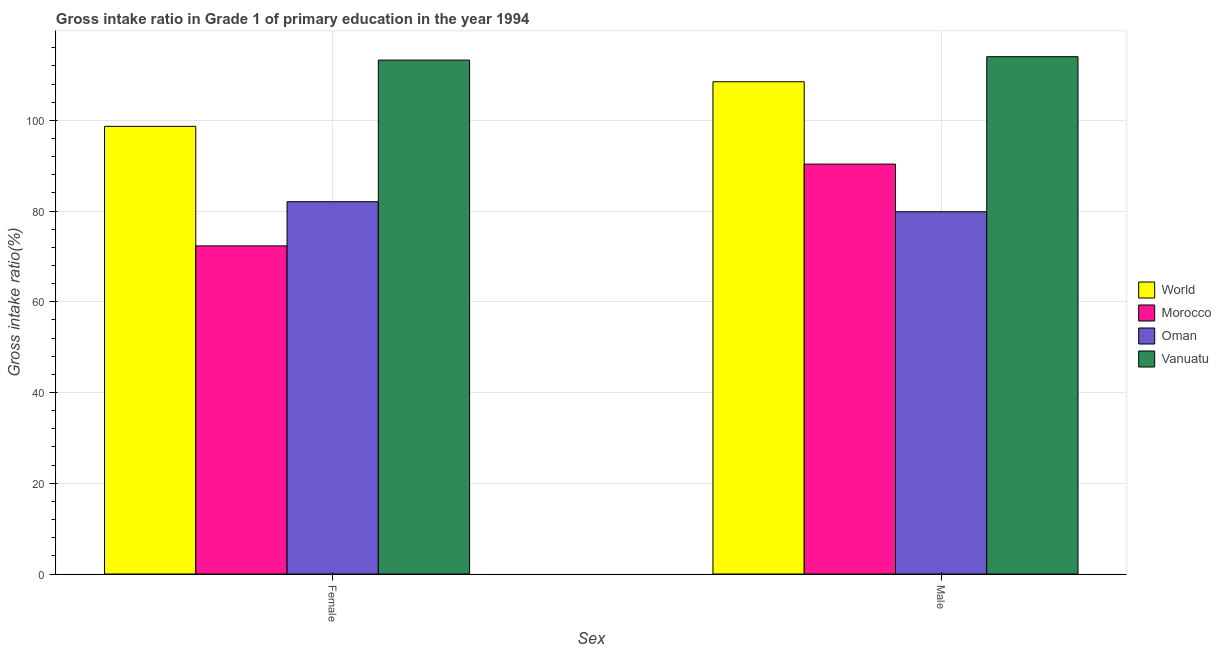How many different coloured bars are there?
Offer a terse response. 4. How many groups of bars are there?
Provide a short and direct response. 2. Are the number of bars on each tick of the X-axis equal?
Ensure brevity in your answer.  Yes. How many bars are there on the 2nd tick from the left?
Your answer should be compact. 4. What is the label of the 2nd group of bars from the left?
Provide a succinct answer. Male. What is the gross intake ratio(male) in Morocco?
Keep it short and to the point. 90.37. Across all countries, what is the maximum gross intake ratio(female)?
Your answer should be very brief. 113.3. Across all countries, what is the minimum gross intake ratio(male)?
Provide a succinct answer. 79.86. In which country was the gross intake ratio(male) maximum?
Your answer should be compact. Vanuatu. In which country was the gross intake ratio(female) minimum?
Offer a very short reply. Morocco. What is the total gross intake ratio(female) in the graph?
Offer a terse response. 366.41. What is the difference between the gross intake ratio(male) in Oman and that in Vanuatu?
Provide a succinct answer. -34.19. What is the difference between the gross intake ratio(female) in Vanuatu and the gross intake ratio(male) in Morocco?
Give a very brief answer. 22.93. What is the average gross intake ratio(female) per country?
Provide a succinct answer. 91.6. What is the difference between the gross intake ratio(male) and gross intake ratio(female) in Morocco?
Your answer should be very brief. 18.03. What is the ratio of the gross intake ratio(female) in Vanuatu to that in World?
Make the answer very short. 1.15. Is the gross intake ratio(male) in Vanuatu less than that in Morocco?
Keep it short and to the point. No. What does the 3rd bar from the left in Female represents?
Make the answer very short. Oman. What does the 1st bar from the right in Female represents?
Make the answer very short. Vanuatu. How many bars are there?
Offer a terse response. 8. Are all the bars in the graph horizontal?
Your answer should be very brief. No. How many countries are there in the graph?
Ensure brevity in your answer.  4. What is the difference between two consecutive major ticks on the Y-axis?
Offer a very short reply. 20. Are the values on the major ticks of Y-axis written in scientific E-notation?
Ensure brevity in your answer.  No. Does the graph contain any zero values?
Offer a very short reply. No. Where does the legend appear in the graph?
Provide a short and direct response. Center right. How many legend labels are there?
Your answer should be very brief. 4. What is the title of the graph?
Keep it short and to the point. Gross intake ratio in Grade 1 of primary education in the year 1994. What is the label or title of the X-axis?
Provide a succinct answer. Sex. What is the label or title of the Y-axis?
Offer a terse response. Gross intake ratio(%). What is the Gross intake ratio(%) in World in Female?
Your answer should be very brief. 98.69. What is the Gross intake ratio(%) of Morocco in Female?
Make the answer very short. 72.34. What is the Gross intake ratio(%) of Oman in Female?
Provide a short and direct response. 82.08. What is the Gross intake ratio(%) of Vanuatu in Female?
Provide a short and direct response. 113.3. What is the Gross intake ratio(%) in World in Male?
Give a very brief answer. 108.52. What is the Gross intake ratio(%) of Morocco in Male?
Make the answer very short. 90.37. What is the Gross intake ratio(%) in Oman in Male?
Offer a very short reply. 79.86. What is the Gross intake ratio(%) of Vanuatu in Male?
Give a very brief answer. 114.05. Across all Sex, what is the maximum Gross intake ratio(%) of World?
Your response must be concise. 108.52. Across all Sex, what is the maximum Gross intake ratio(%) in Morocco?
Make the answer very short. 90.37. Across all Sex, what is the maximum Gross intake ratio(%) of Oman?
Keep it short and to the point. 82.08. Across all Sex, what is the maximum Gross intake ratio(%) in Vanuatu?
Make the answer very short. 114.05. Across all Sex, what is the minimum Gross intake ratio(%) in World?
Your response must be concise. 98.69. Across all Sex, what is the minimum Gross intake ratio(%) of Morocco?
Provide a short and direct response. 72.34. Across all Sex, what is the minimum Gross intake ratio(%) in Oman?
Offer a very short reply. 79.86. Across all Sex, what is the minimum Gross intake ratio(%) of Vanuatu?
Keep it short and to the point. 113.3. What is the total Gross intake ratio(%) of World in the graph?
Make the answer very short. 207.21. What is the total Gross intake ratio(%) of Morocco in the graph?
Provide a succinct answer. 162.71. What is the total Gross intake ratio(%) of Oman in the graph?
Ensure brevity in your answer.  161.94. What is the total Gross intake ratio(%) of Vanuatu in the graph?
Keep it short and to the point. 227.35. What is the difference between the Gross intake ratio(%) in World in Female and that in Male?
Ensure brevity in your answer.  -9.83. What is the difference between the Gross intake ratio(%) in Morocco in Female and that in Male?
Make the answer very short. -18.03. What is the difference between the Gross intake ratio(%) in Oman in Female and that in Male?
Your answer should be very brief. 2.21. What is the difference between the Gross intake ratio(%) in Vanuatu in Female and that in Male?
Provide a succinct answer. -0.75. What is the difference between the Gross intake ratio(%) in World in Female and the Gross intake ratio(%) in Morocco in Male?
Ensure brevity in your answer.  8.32. What is the difference between the Gross intake ratio(%) in World in Female and the Gross intake ratio(%) in Oman in Male?
Make the answer very short. 18.83. What is the difference between the Gross intake ratio(%) of World in Female and the Gross intake ratio(%) of Vanuatu in Male?
Ensure brevity in your answer.  -15.36. What is the difference between the Gross intake ratio(%) in Morocco in Female and the Gross intake ratio(%) in Oman in Male?
Provide a short and direct response. -7.52. What is the difference between the Gross intake ratio(%) in Morocco in Female and the Gross intake ratio(%) in Vanuatu in Male?
Your response must be concise. -41.71. What is the difference between the Gross intake ratio(%) in Oman in Female and the Gross intake ratio(%) in Vanuatu in Male?
Offer a very short reply. -31.97. What is the average Gross intake ratio(%) of World per Sex?
Your response must be concise. 103.61. What is the average Gross intake ratio(%) of Morocco per Sex?
Provide a short and direct response. 81.35. What is the average Gross intake ratio(%) in Oman per Sex?
Give a very brief answer. 80.97. What is the average Gross intake ratio(%) in Vanuatu per Sex?
Give a very brief answer. 113.68. What is the difference between the Gross intake ratio(%) of World and Gross intake ratio(%) of Morocco in Female?
Your response must be concise. 26.35. What is the difference between the Gross intake ratio(%) in World and Gross intake ratio(%) in Oman in Female?
Keep it short and to the point. 16.62. What is the difference between the Gross intake ratio(%) in World and Gross intake ratio(%) in Vanuatu in Female?
Your answer should be very brief. -14.61. What is the difference between the Gross intake ratio(%) in Morocco and Gross intake ratio(%) in Oman in Female?
Keep it short and to the point. -9.74. What is the difference between the Gross intake ratio(%) of Morocco and Gross intake ratio(%) of Vanuatu in Female?
Give a very brief answer. -40.96. What is the difference between the Gross intake ratio(%) of Oman and Gross intake ratio(%) of Vanuatu in Female?
Ensure brevity in your answer.  -31.23. What is the difference between the Gross intake ratio(%) of World and Gross intake ratio(%) of Morocco in Male?
Provide a succinct answer. 18.15. What is the difference between the Gross intake ratio(%) of World and Gross intake ratio(%) of Oman in Male?
Offer a terse response. 28.66. What is the difference between the Gross intake ratio(%) of World and Gross intake ratio(%) of Vanuatu in Male?
Provide a succinct answer. -5.53. What is the difference between the Gross intake ratio(%) in Morocco and Gross intake ratio(%) in Oman in Male?
Offer a terse response. 10.51. What is the difference between the Gross intake ratio(%) of Morocco and Gross intake ratio(%) of Vanuatu in Male?
Your response must be concise. -23.68. What is the difference between the Gross intake ratio(%) in Oman and Gross intake ratio(%) in Vanuatu in Male?
Your response must be concise. -34.19. What is the ratio of the Gross intake ratio(%) of World in Female to that in Male?
Offer a very short reply. 0.91. What is the ratio of the Gross intake ratio(%) of Morocco in Female to that in Male?
Make the answer very short. 0.8. What is the ratio of the Gross intake ratio(%) of Oman in Female to that in Male?
Offer a terse response. 1.03. What is the difference between the highest and the second highest Gross intake ratio(%) in World?
Your answer should be compact. 9.83. What is the difference between the highest and the second highest Gross intake ratio(%) of Morocco?
Keep it short and to the point. 18.03. What is the difference between the highest and the second highest Gross intake ratio(%) in Oman?
Provide a succinct answer. 2.21. What is the difference between the highest and the second highest Gross intake ratio(%) in Vanuatu?
Ensure brevity in your answer.  0.75. What is the difference between the highest and the lowest Gross intake ratio(%) in World?
Offer a terse response. 9.83. What is the difference between the highest and the lowest Gross intake ratio(%) in Morocco?
Offer a very short reply. 18.03. What is the difference between the highest and the lowest Gross intake ratio(%) of Oman?
Offer a very short reply. 2.21. What is the difference between the highest and the lowest Gross intake ratio(%) of Vanuatu?
Keep it short and to the point. 0.75. 